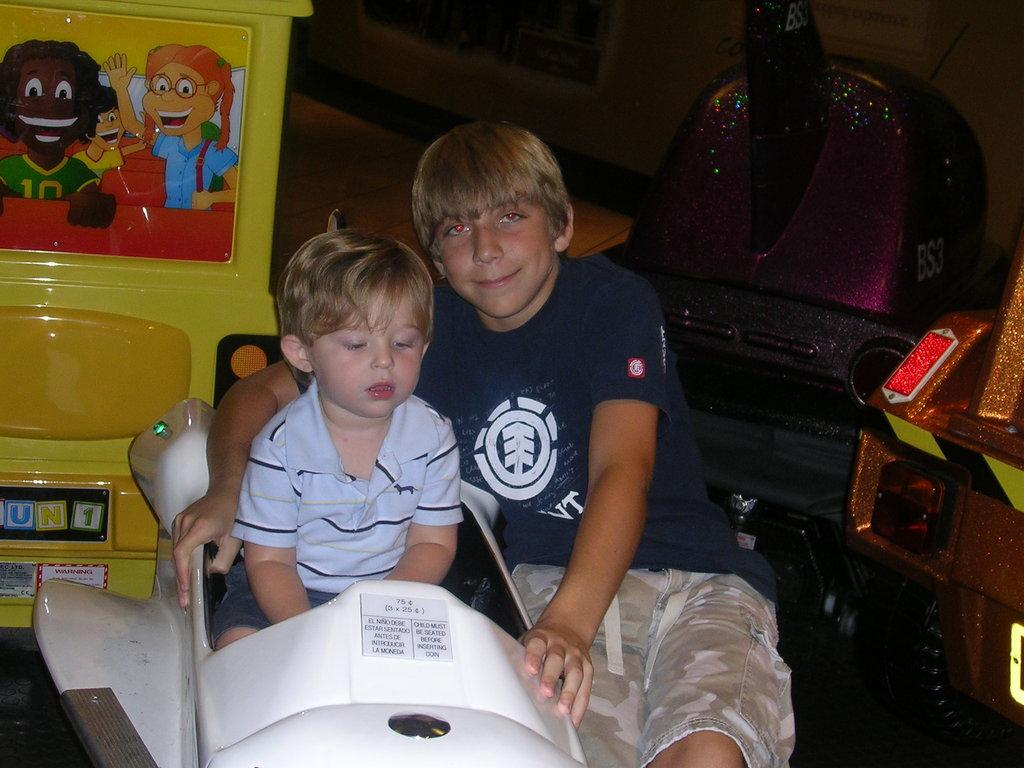How many boys are in the image? There are two boys in the image. What is the expression on the face of the first boy? The first boy is smiling. What is the second boy doing in the image? The second boy is sitting on a vehicle. What can be seen behind the boys in the image? There are objects visible behind the boys. How would you describe the lighting in the image? The background of the image is dark. What type of curtain is hanging from the tramp in the image? There is no tramp or curtain present in the image. How does the second boy maintain his balance while sitting on the vehicle? The image does not show the second boy maintaining his balance, as he is simply sitting on the vehicle. 